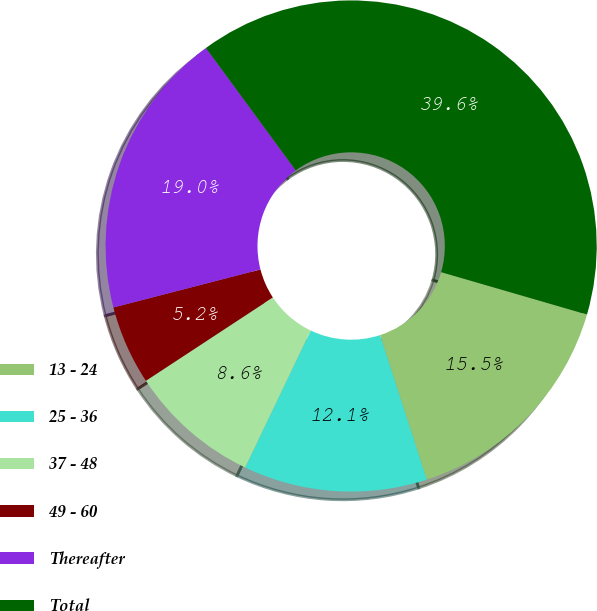Convert chart. <chart><loc_0><loc_0><loc_500><loc_500><pie_chart><fcel>13 - 24<fcel>25 - 36<fcel>37 - 48<fcel>49 - 60<fcel>Thereafter<fcel>Total<nl><fcel>15.52%<fcel>12.09%<fcel>8.65%<fcel>5.22%<fcel>18.96%<fcel>39.57%<nl></chart> 